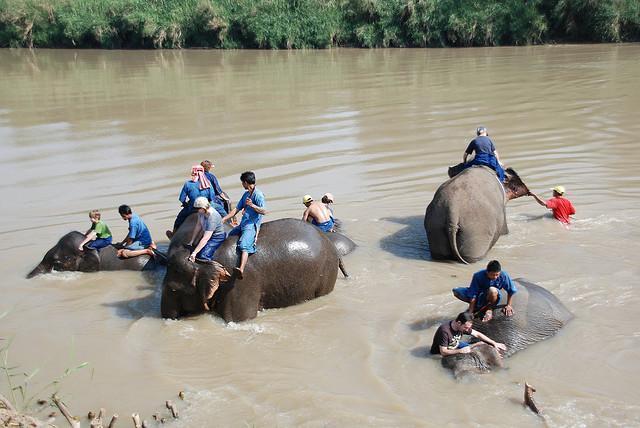How many elephants can you see?
Give a very brief answer. 4. How many people are there?
Give a very brief answer. 2. How many skateboards are visible?
Give a very brief answer. 0. 